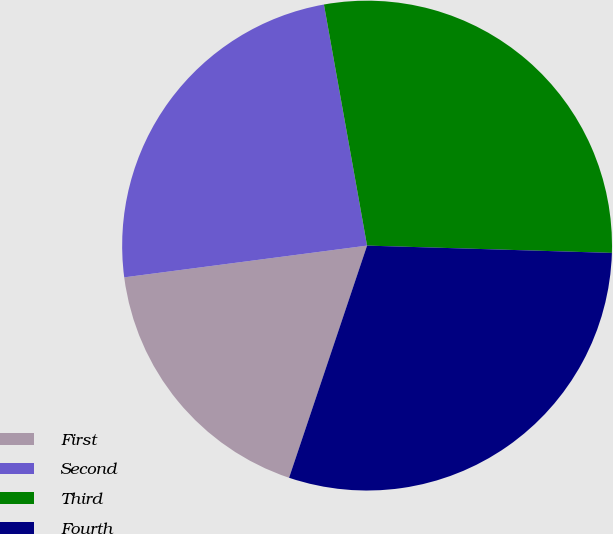Convert chart. <chart><loc_0><loc_0><loc_500><loc_500><pie_chart><fcel>First<fcel>Second<fcel>Third<fcel>Fourth<nl><fcel>17.77%<fcel>24.25%<fcel>28.29%<fcel>29.68%<nl></chart> 